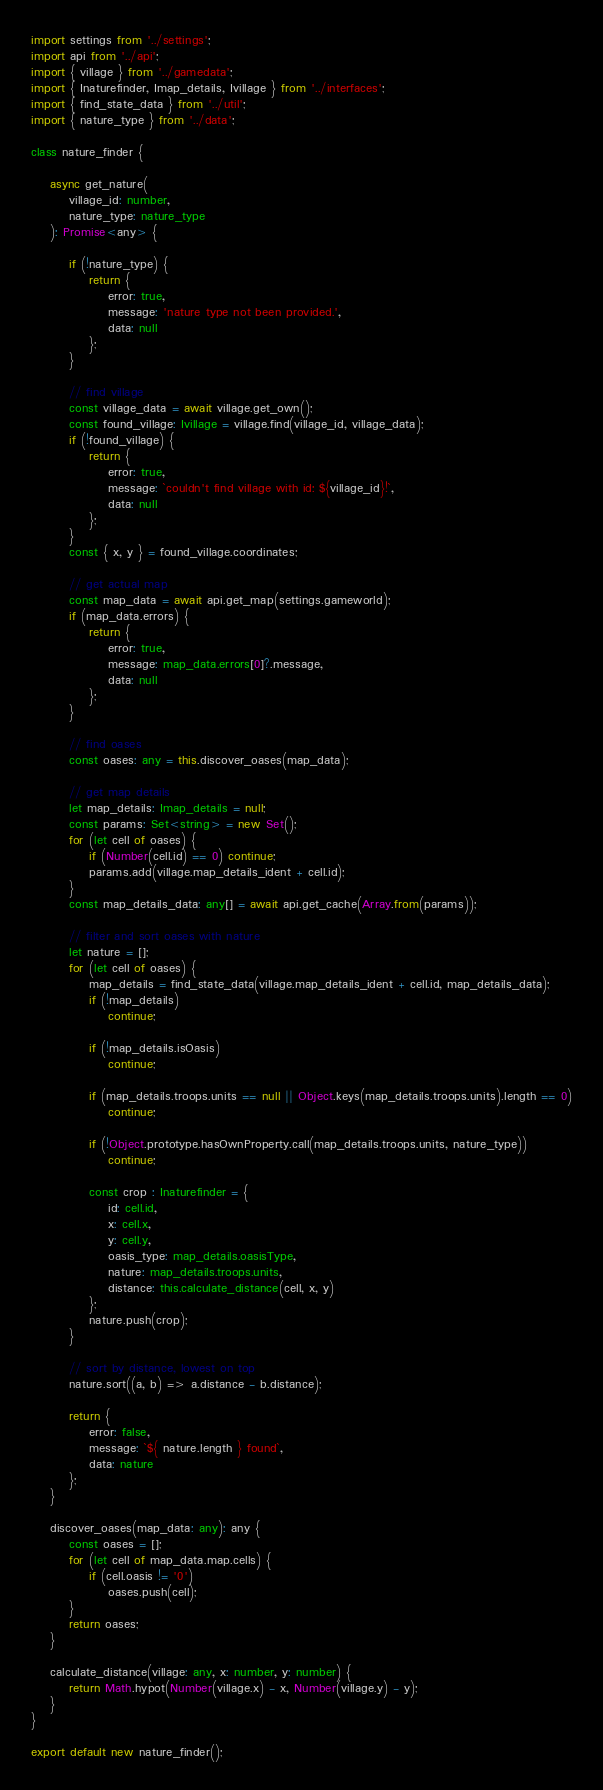<code> <loc_0><loc_0><loc_500><loc_500><_TypeScript_>import settings from '../settings';
import api from '../api';
import { village } from '../gamedata';
import { Inaturefinder, Imap_details, Ivillage } from '../interfaces';
import { find_state_data } from '../util';
import { nature_type } from '../data';

class nature_finder {

	async get_nature(
		village_id: number,
		nature_type: nature_type
	): Promise<any> {

		if (!nature_type) {
			return {
				error: true,
				message: 'nature type not been provided.',
				data: null
			};
		}

		// find village
		const village_data = await village.get_own();
		const found_village: Ivillage = village.find(village_id, village_data);
		if (!found_village) {
			return {
				error: true,
				message: `couldn't find village with id: ${village_id}!`,
				data: null
			};
		}
		const { x, y } = found_village.coordinates;

		// get actual map
		const map_data = await api.get_map(settings.gameworld);
		if (map_data.errors) {
			return {
				error: true,
				message: map_data.errors[0]?.message,
				data: null
			};
		}

		// find oases
		const oases: any = this.discover_oases(map_data);

		// get map details
		let map_details: Imap_details = null;
		const params: Set<string> = new Set();
		for (let cell of oases) {
			if (Number(cell.id) == 0) continue;
			params.add(village.map_details_ident + cell.id);
		}
		const map_details_data: any[] = await api.get_cache(Array.from(params));

		// filter and sort oases with nature
		let nature = [];
		for (let cell of oases) {
			map_details = find_state_data(village.map_details_ident + cell.id, map_details_data);
			if (!map_details)
				continue;

			if (!map_details.isOasis)
				continue;

			if (map_details.troops.units == null || Object.keys(map_details.troops.units).length == 0)
				continue;

			if (!Object.prototype.hasOwnProperty.call(map_details.troops.units, nature_type))
				continue;

			const crop : Inaturefinder = {
				id: cell.id,
				x: cell.x,
				y: cell.y,
				oasis_type: map_details.oasisType,
				nature: map_details.troops.units,
				distance: this.calculate_distance(cell, x, y)
			};
			nature.push(crop);
		}

		// sort by distance, lowest on top
		nature.sort((a, b) => a.distance - b.distance);

		return {
			error: false,
			message: `${ nature.length } found`,
			data: nature
		};
	}

	discover_oases(map_data: any): any {
		const oases = [];
		for (let cell of map_data.map.cells) {
			if (cell.oasis != '0')
				oases.push(cell);
		}
		return oases;
	}

	calculate_distance(village: any, x: number, y: number) {
		return Math.hypot(Number(village.x) - x, Number(village.y) - y);
	}
}

export default new nature_finder();
</code> 